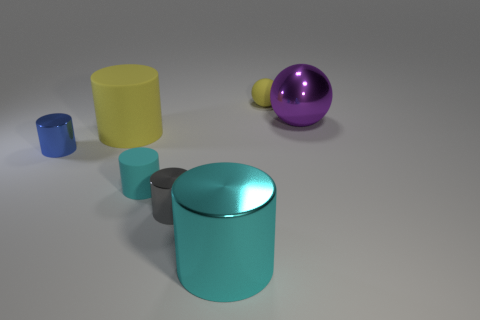How many other things are made of the same material as the tiny blue thing?
Provide a succinct answer. 3. There is a yellow thing that is the same shape as the big cyan metallic thing; what size is it?
Your answer should be very brief. Large. Does the small matte ball have the same color as the big rubber cylinder?
Provide a succinct answer. Yes. The small thing that is both right of the cyan rubber object and in front of the yellow matte ball is what color?
Offer a very short reply. Gray. What number of objects are either tiny rubber cylinders to the left of the gray object or large cylinders?
Provide a short and direct response. 3. The tiny rubber thing that is the same shape as the small gray shiny thing is what color?
Offer a very short reply. Cyan. Does the big yellow object have the same shape as the matte object in front of the small blue thing?
Keep it short and to the point. Yes. What number of things are either small objects right of the gray metal thing or matte things that are behind the small blue object?
Keep it short and to the point. 2. Are there fewer blue shiny cylinders that are behind the blue cylinder than yellow cylinders?
Offer a very short reply. Yes. Do the big yellow object and the small sphere that is behind the small cyan rubber thing have the same material?
Give a very brief answer. Yes. 